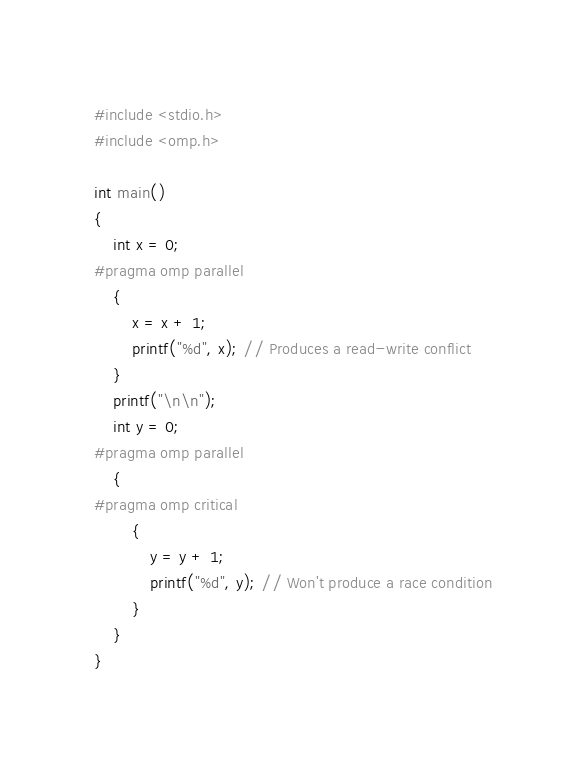Convert code to text. <code><loc_0><loc_0><loc_500><loc_500><_C_>#include <stdio.h>
#include <omp.h>

int main()
{
    int x = 0;
#pragma omp parallel
    {
        x = x + 1;
        printf("%d", x); // Produces a read-write conflict
    }
    printf("\n\n");
    int y = 0;
#pragma omp parallel
    {
#pragma omp critical
        {
            y = y + 1;
            printf("%d", y); // Won't produce a race condition
        }
    }
}</code> 